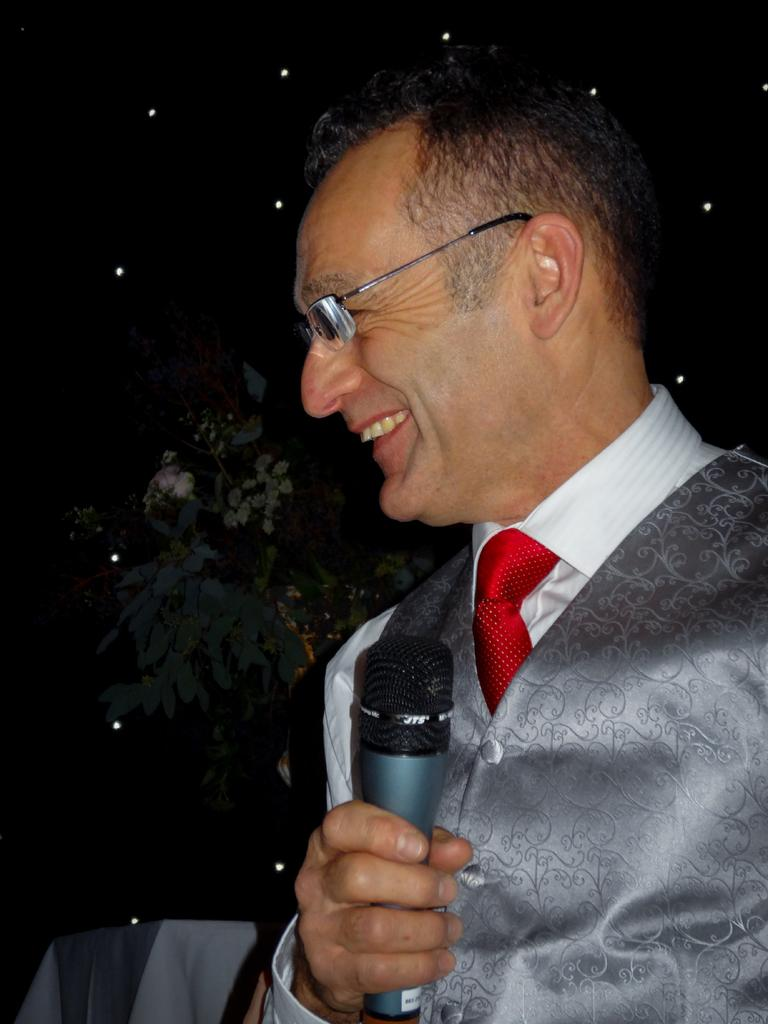What is the man in the image holding? The man is holding a microphone. What is the man's facial expression in the image? The man is smiling. What type of clothing is the man wearing in the image? The man is wearing a vest coat and glasses. What can be seen in the background of the image? There is a tree in the background of the image. How many pizzas are visible in the image? There are no pizzas present in the image. What type of star can be seen in the image? There is no star visible in the image. 